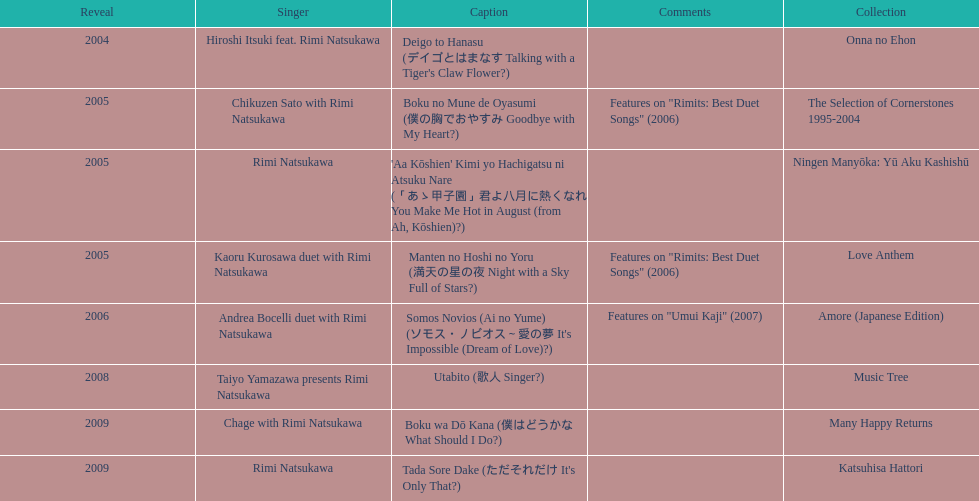Which was released earlier, deigo to hanasu or utabito? Deigo to Hanasu. 